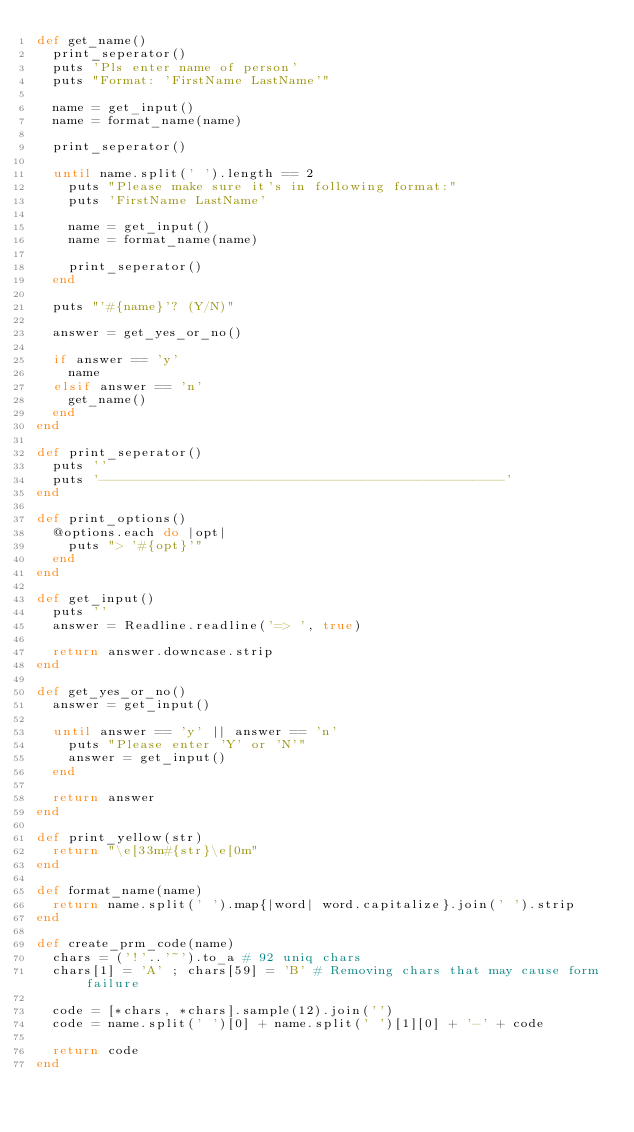Convert code to text. <code><loc_0><loc_0><loc_500><loc_500><_Ruby_>def get_name()
  print_seperator()
  puts 'Pls enter name of person'
  puts "Format: 'FirstName LastName'"
  
  name = get_input()
  name = format_name(name)

  print_seperator()

  until name.split(' ').length == 2
    puts "Please make sure it's in following format:"
    puts 'FirstName LastName'

    name = get_input()
    name = format_name(name)

    print_seperator()
  end

  puts "'#{name}'? (Y/N)"
  
  answer = get_yes_or_no()

  if answer == 'y'
    name
  elsif answer == 'n'
    get_name()
  end
end

def print_seperator()
  puts ''
  puts '---------------------------------------------------'
end

def print_options()
  @options.each do |opt|
    puts "> '#{opt}'"
  end
end

def get_input()
  puts ''
  answer = Readline.readline('=> ', true)

  return answer.downcase.strip
end

def get_yes_or_no()
  answer = get_input()
  
  until answer == 'y' || answer == 'n'
    puts "Please enter 'Y' or 'N'"
    answer = get_input()
  end

  return answer
end

def print_yellow(str)
  return "\e[33m#{str}\e[0m"
end

def format_name(name)
  return name.split(' ').map{|word| word.capitalize}.join(' ').strip
end

def create_prm_code(name)
  chars = ('!'..'~').to_a # 92 uniq chars
  chars[1] = 'A' ; chars[59] = 'B' # Removing chars that may cause form failure

  code = [*chars, *chars].sample(12).join('')
  code = name.split(' ')[0] + name.split(' ')[1][0] + '-' + code

  return code
end
</code> 